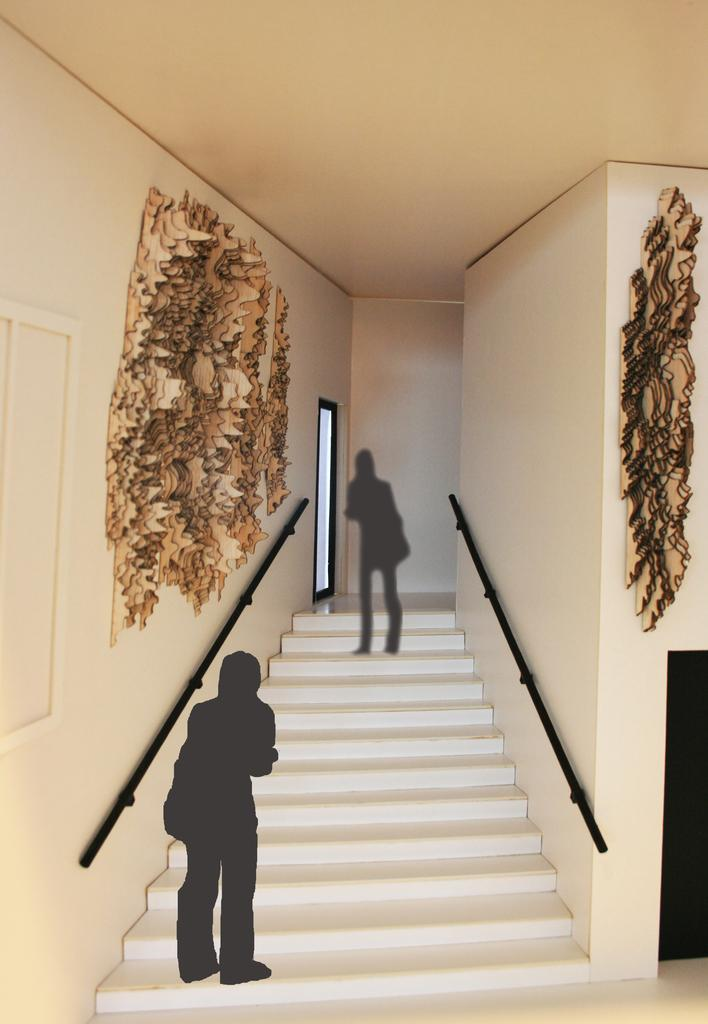What type of location is depicted in the image? The image shows an inside view of a building. What can be seen in the foreground of the image? There are stairs in front in the image. What is the color of the objects on the stairs? The objects on the stairs are black in color. What can be observed on the walls in the image? There are brown color things on the walls. What type of weather can be seen through the windows in the image? There are no windows visible in the image, so it is not possible to determine the weather. 